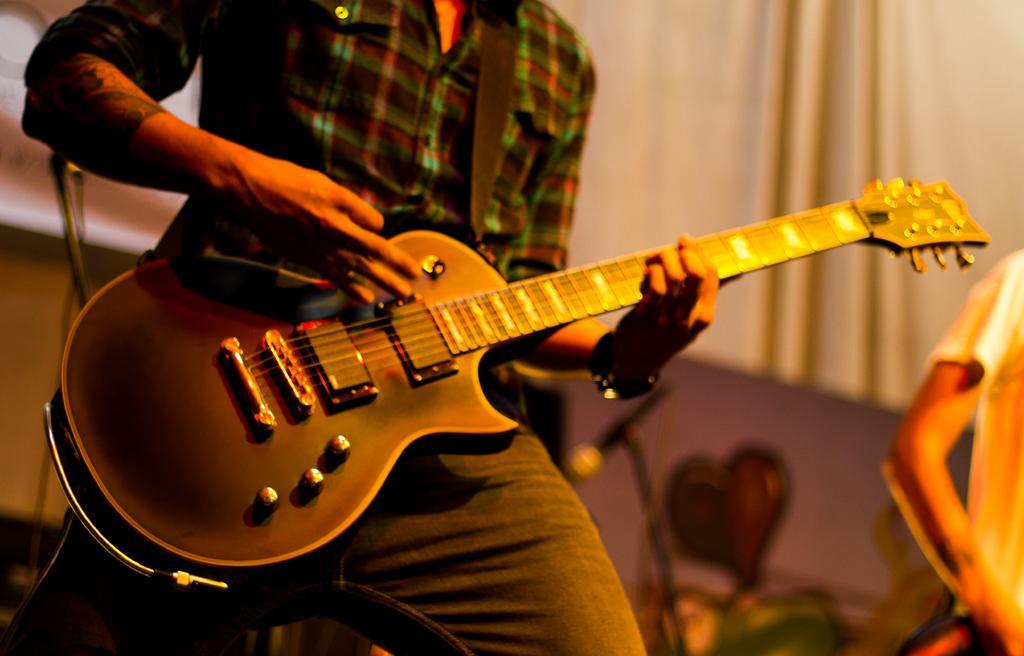In one or two sentences, can you explain what this image depicts? In the given image we can see that a man holding guitar in his hand. 